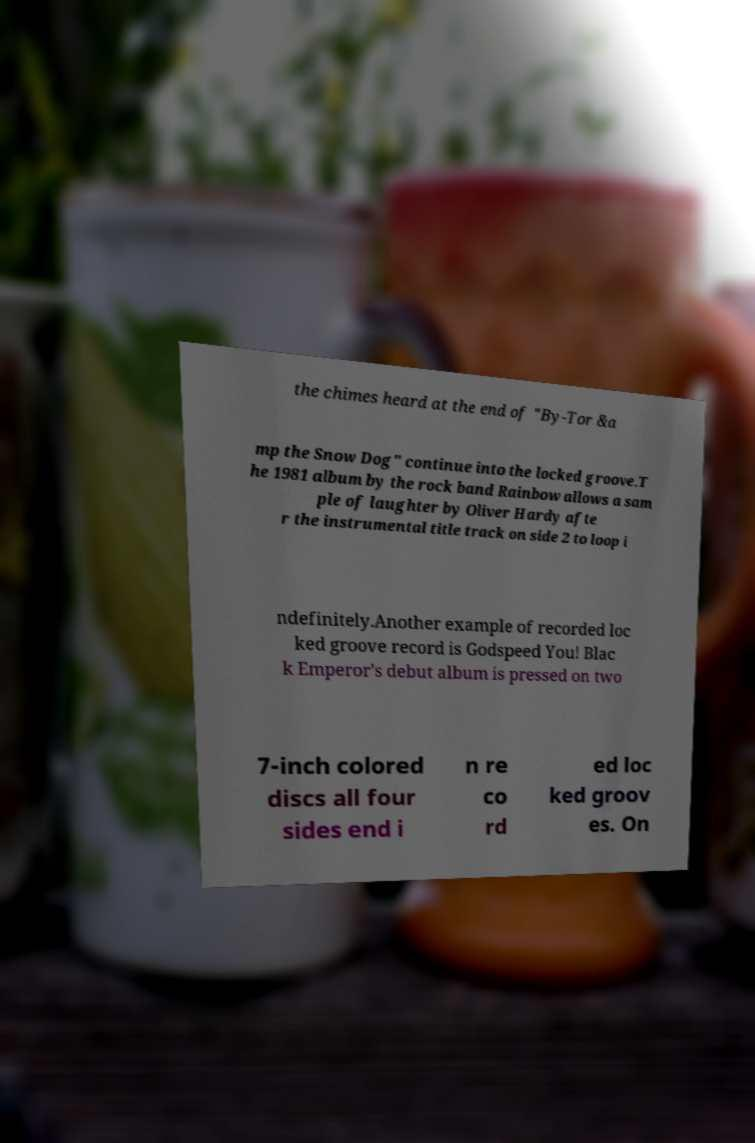Can you accurately transcribe the text from the provided image for me? the chimes heard at the end of "By-Tor &a mp the Snow Dog" continue into the locked groove.T he 1981 album by the rock band Rainbow allows a sam ple of laughter by Oliver Hardy afte r the instrumental title track on side 2 to loop i ndefinitely.Another example of recorded loc ked groove record is Godspeed You! Blac k Emperor's debut album is pressed on two 7-inch colored discs all four sides end i n re co rd ed loc ked groov es. On 